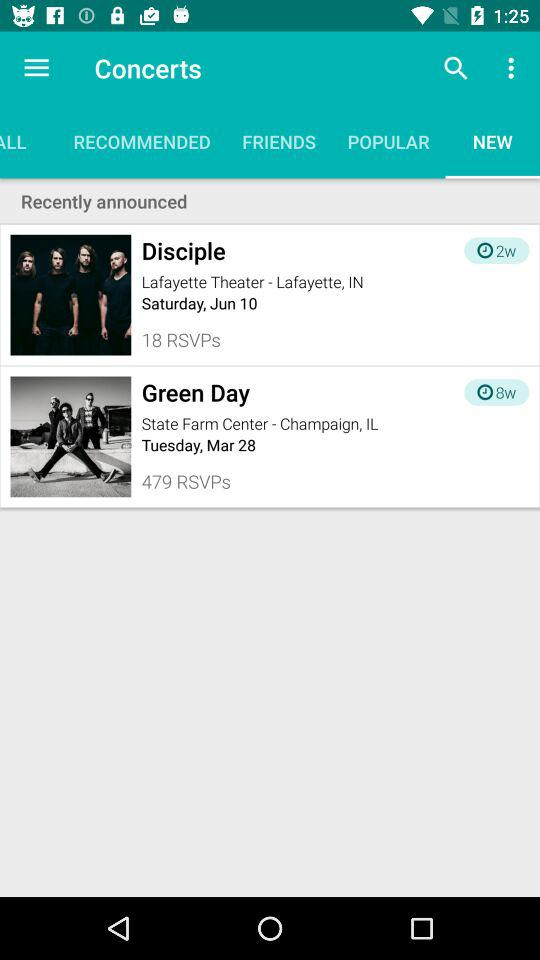In which theater is the concert by "Disciple" to be performed? The concert by "Disciple" is to be performed in the "Lafayette Theater". 